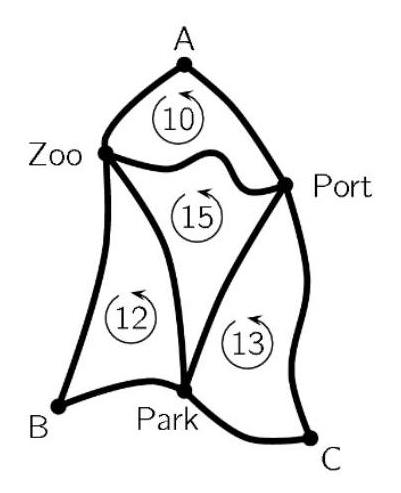The map shows three bus stations at points $A, B$ and $C$. A tour from station $A$ to the Zoo and the Port and back to $A$ is $10 \mathrm{~km}$ long. $A$ tour from station $B$ to the Park and the Zoo and back to B is $12 \mathrm{~km}$ long. A tour from station C to the Port and the Park and back to $C$ is $13 \mathrm{~km}$ long. Also, A tour from the Zoo to the Park and the Port and back to the Zoo is $15 \mathrm{~km}$ long. How long is the shortest tour from A to B to $C$ and back to $A$? To determine the shortest tour from A to B to C and back to A, we need to understand the defined distances between these tourist attractions and plan the most efficient path. The distances between Zoo, Park, and Port, which are the respective midpoints between A, B, and C, can be identified from the circumference of the tours provided. By analyzing these midpoints, determining the side lengths of each segment between the bus stations A, B, and C, and calculating the routes, the shortest path can be derived. Given the options, the shortest path in this context considering each side approximately equals the sum of segments and is nearly symmetrical would plausibly be the one from option '$20 \mathrm{~km}$'. 